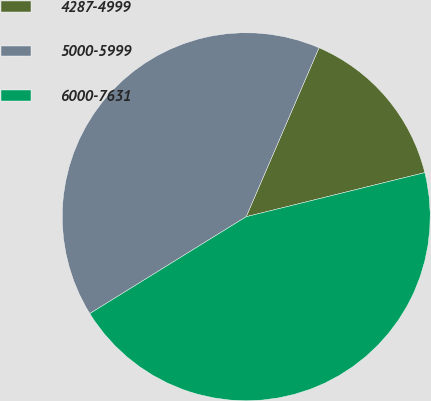Convert chart to OTSL. <chart><loc_0><loc_0><loc_500><loc_500><pie_chart><fcel>4287-4999<fcel>5000-5999<fcel>6000-7631<nl><fcel>14.67%<fcel>40.3%<fcel>45.03%<nl></chart> 